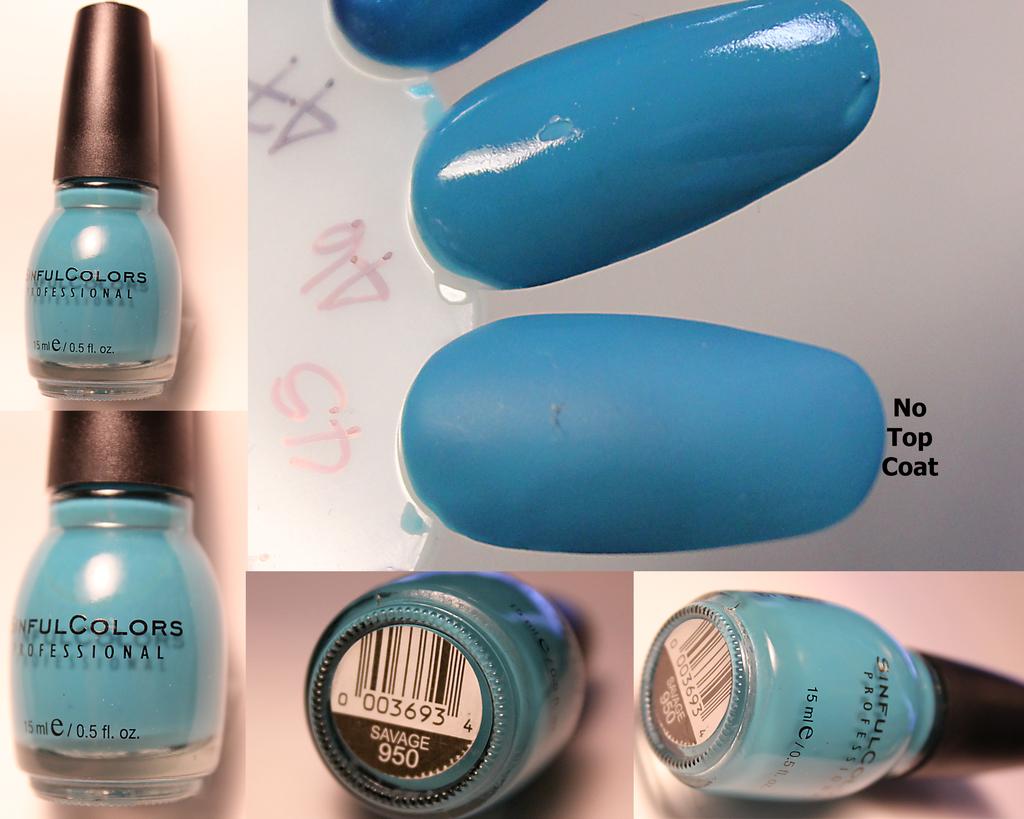How many fluid ounces are in the jar?
Ensure brevity in your answer.  0.5. What is the serial number>?
Your response must be concise. 003693. 